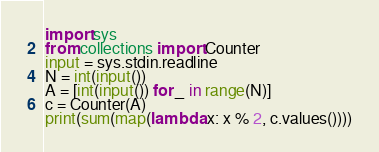<code> <loc_0><loc_0><loc_500><loc_500><_Python_>import sys
from collections import Counter
input = sys.stdin.readline
N = int(input())
A = [int(input()) for _ in range(N)]
c = Counter(A)
print(sum(map(lambda x: x % 2, c.values())))</code> 